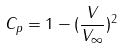Convert formula to latex. <formula><loc_0><loc_0><loc_500><loc_500>C _ { p } = 1 - ( \frac { V } { V _ { \infty } } ) ^ { 2 }</formula> 